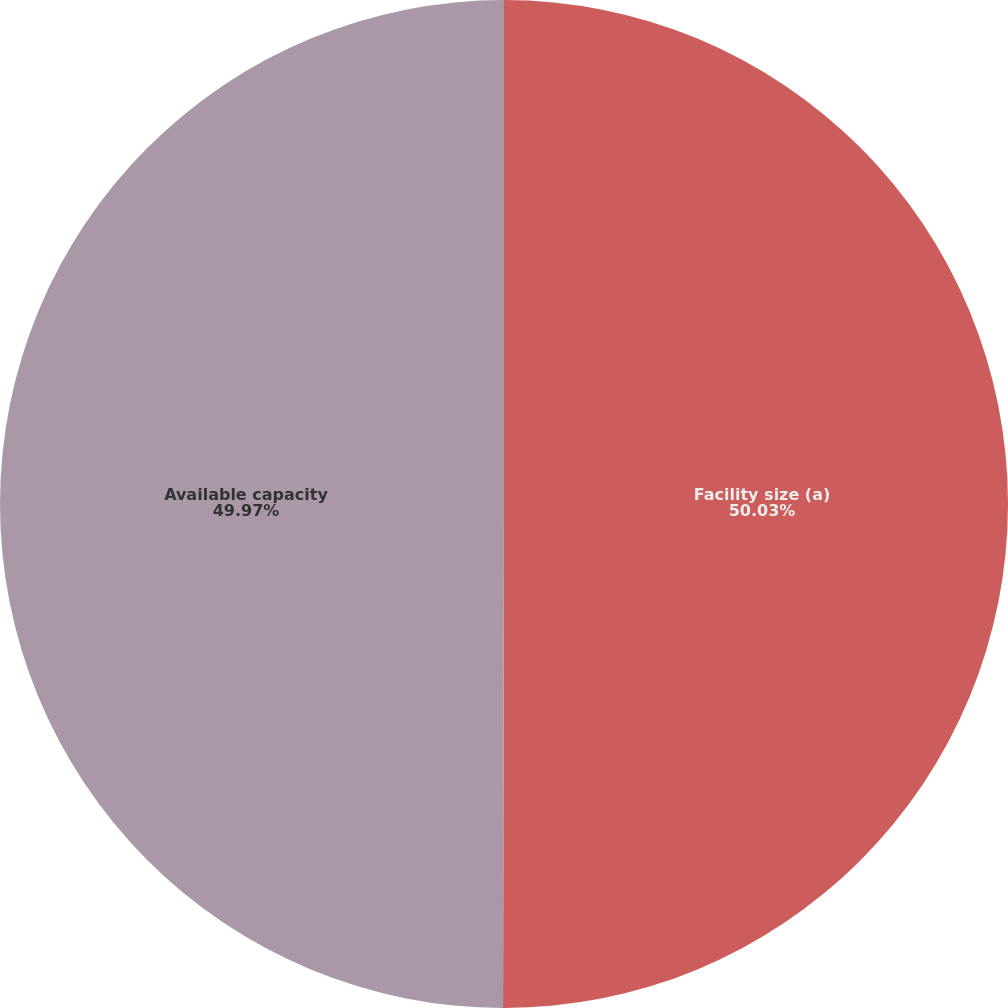<chart> <loc_0><loc_0><loc_500><loc_500><pie_chart><fcel>Facility size (a)<fcel>Available capacity<nl><fcel>50.03%<fcel>49.97%<nl></chart> 